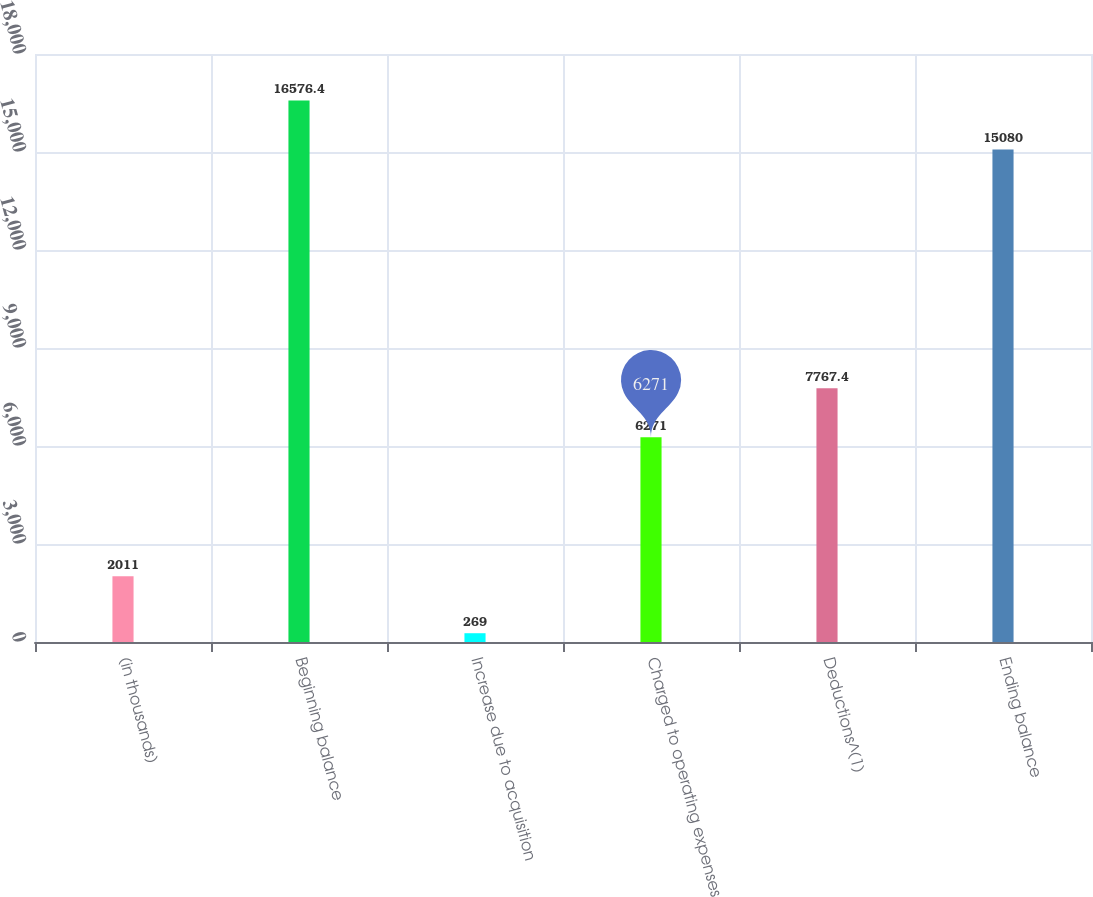<chart> <loc_0><loc_0><loc_500><loc_500><bar_chart><fcel>(in thousands)<fcel>Beginning balance<fcel>Increase due to acquisition<fcel>Charged to operating expenses<fcel>Deductions^(1)<fcel>Ending balance<nl><fcel>2011<fcel>16576.4<fcel>269<fcel>6271<fcel>7767.4<fcel>15080<nl></chart> 